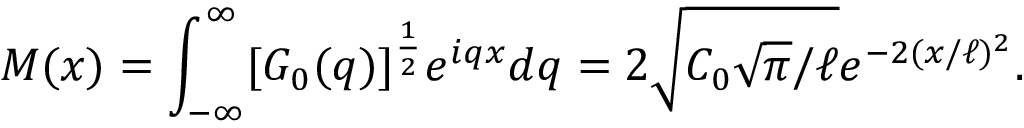<formula> <loc_0><loc_0><loc_500><loc_500>M ( x ) = \int _ { - \infty } ^ { \infty } [ G _ { 0 } ( q ) ] ^ { \frac { 1 } { 2 } } e ^ { i q x } d q = 2 \sqrt { C _ { 0 } \sqrt { \pi } / \ell } e ^ { - 2 ( x / \ell ) ^ { 2 } } .</formula> 